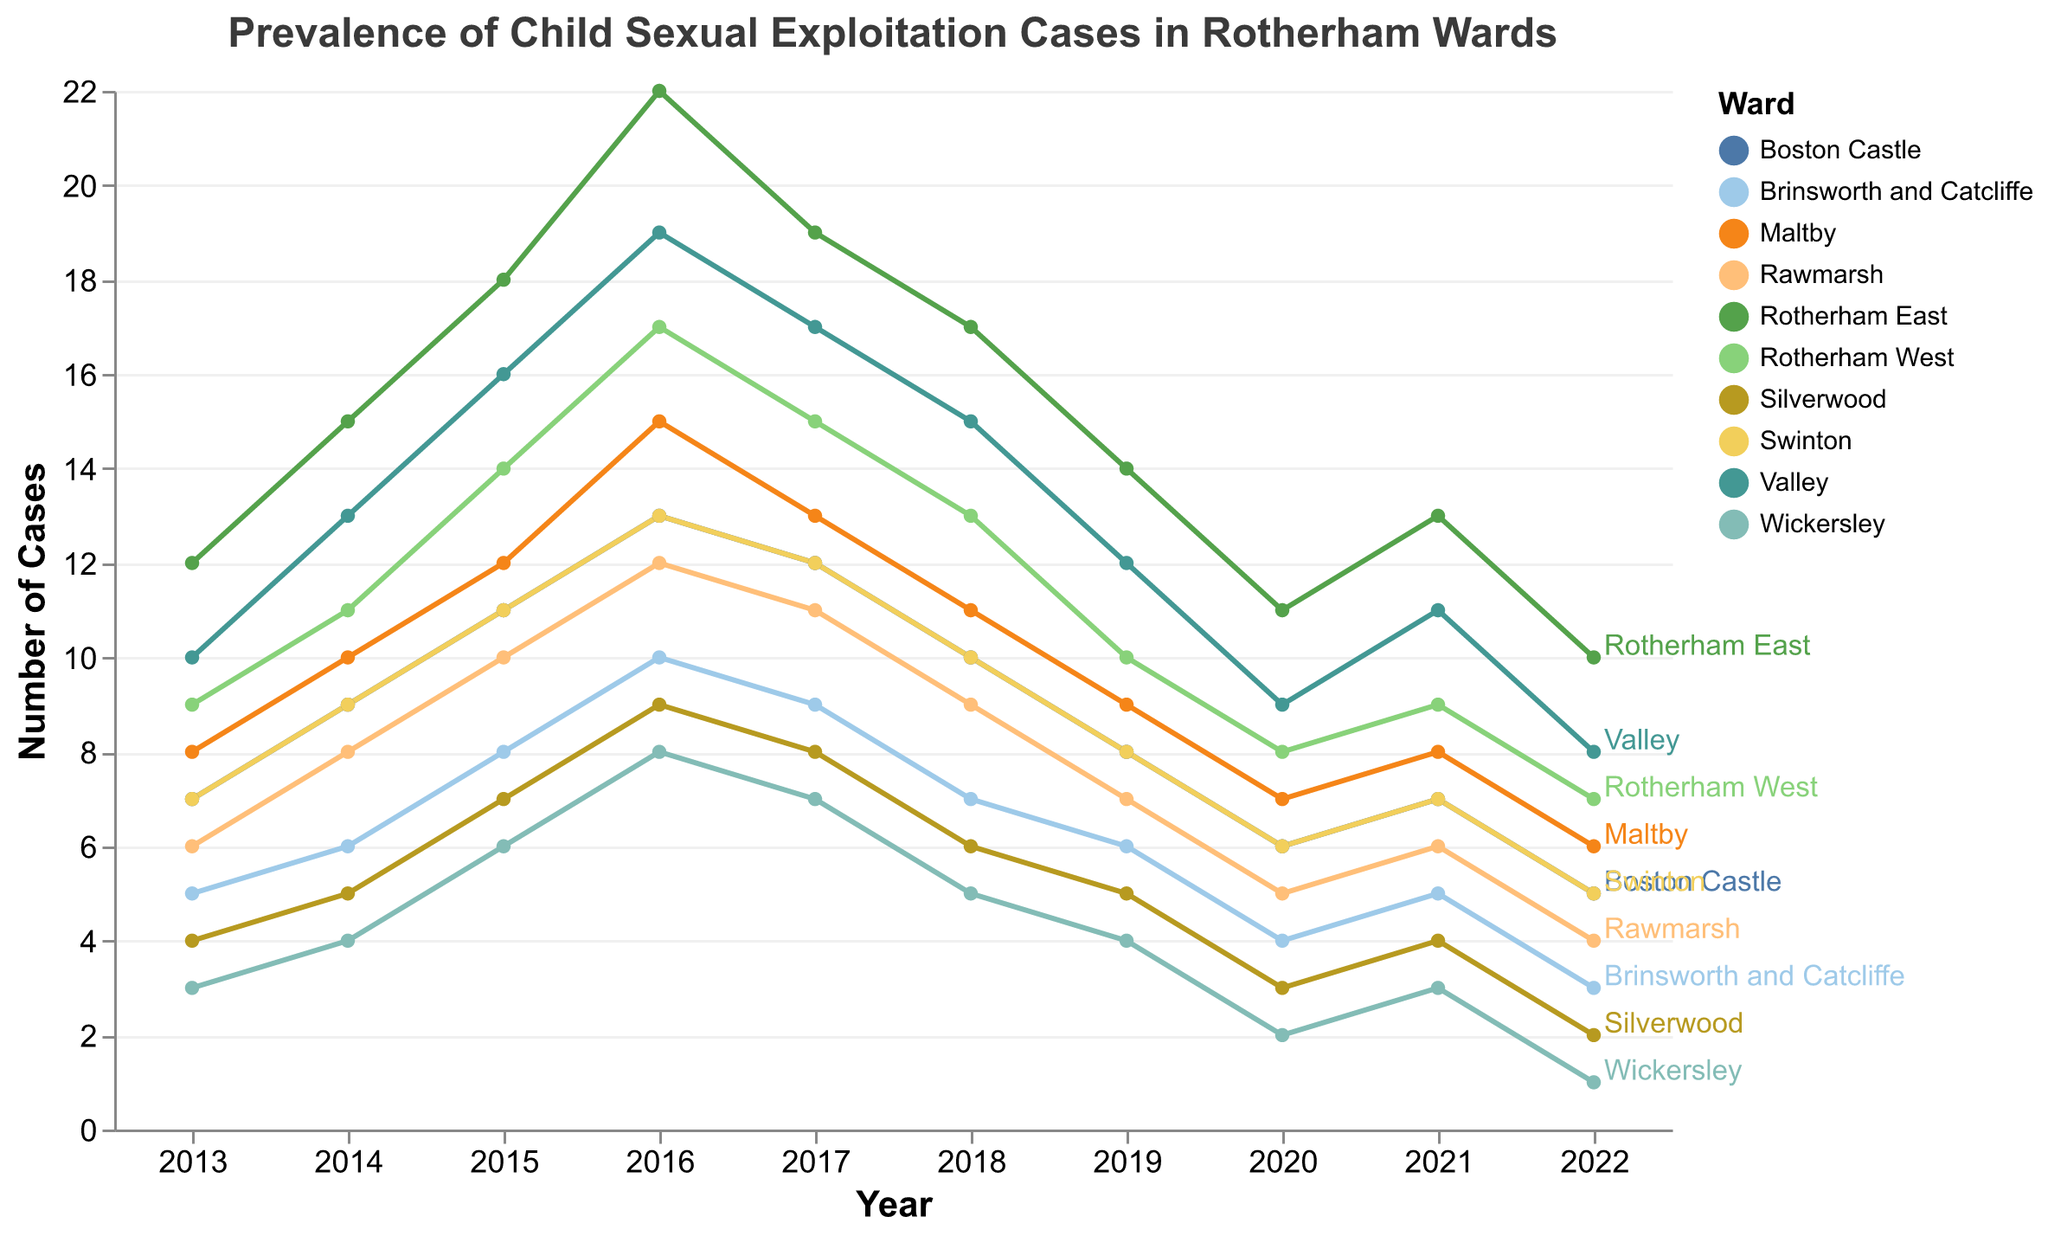What is the title of the plot? The title is displayed at the top of the plot in bold.
Answer: Prevalence of Child Sexual Exploitation Cases in Rotherham Wards Which ward had the highest number of cases in 2022? The line for each ward is labeled at its endpoint in 2022, and the Rotherham East line ends at 10 cases in 2022.
Answer: Rotherham East How many cases were reported in the Valley ward in 2017? Locate the line and point for Valley ward on the year 2017.
Answer: 17 Which ward shows the greatest decrease in cases from 2019 to 2022? Compare the decrease between 2019 and 2022 for each ward by examining the plot lines and their end points. Silverwood decreases from 5 to 2, the largest drop.
Answer: Silverwood How do the trends of cases in Rotherham East and Rotherham West compare over the decade? Observe the line charts for both Rotherham East and Rotherham West over all the years. Both wards show an initial increase, peaking around 2016/2017, followed by a steady decrease.
Answer: Both wards had a rise and a subsequent decline Which ward had the lowest number of cases in 2013? Look for the lowest starting point on the left side of the chart. Wickersley starts with only 3 cases in 2013.
Answer: Wickersley What was the total number of cases across all wards in 2018? Sum the y-values (number of cases) for all wards in 2018. 17+13+10+7+11+9+6+10+15+5 = 103
Answer: 103 Between which years did Boston Castle see the steepest increase in cases? Observe the slope of the lines for Boston Castle and note the steepest incline, which occurs from 2014 to 2016.
Answer: 2014 to 2016 In general, did the number of cases increase or decrease for most wards by 2022 compared to 2013? Compare initial (2013) and final (2022) points for each line. Most lines slope downward toward 2022.
Answer: Decrease 